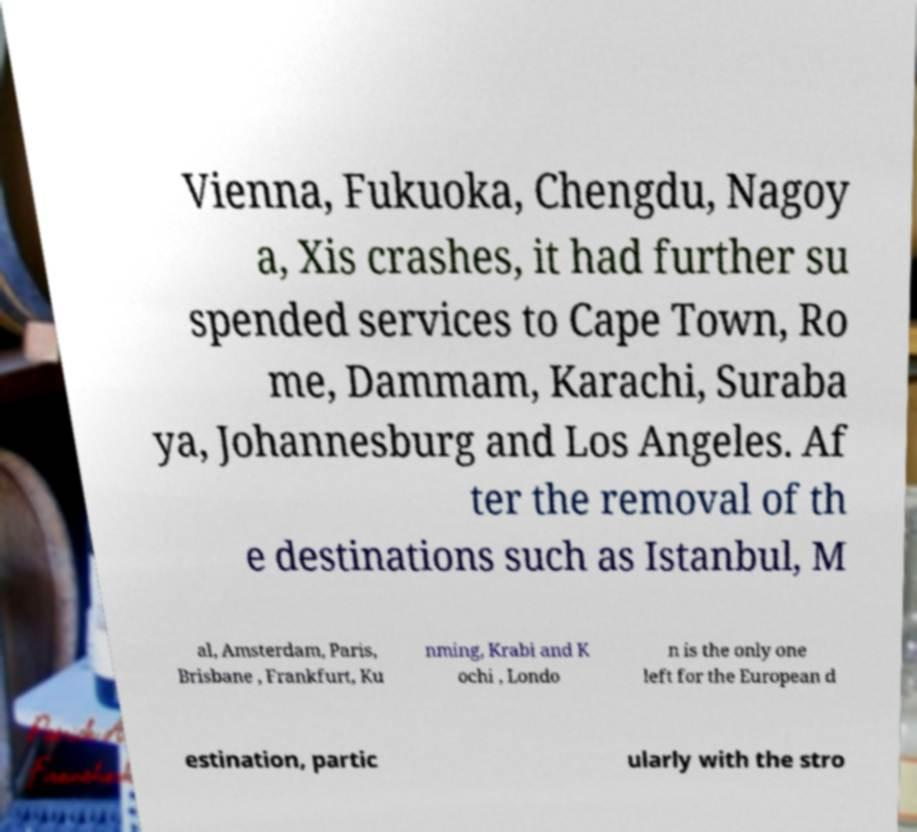Please read and relay the text visible in this image. What does it say? Vienna, Fukuoka, Chengdu, Nagoy a, Xis crashes, it had further su spended services to Cape Town, Ro me, Dammam, Karachi, Suraba ya, Johannesburg and Los Angeles. Af ter the removal of th e destinations such as Istanbul, M al, Amsterdam, Paris, Brisbane , Frankfurt, Ku nming, Krabi and K ochi , Londo n is the only one left for the European d estination, partic ularly with the stro 